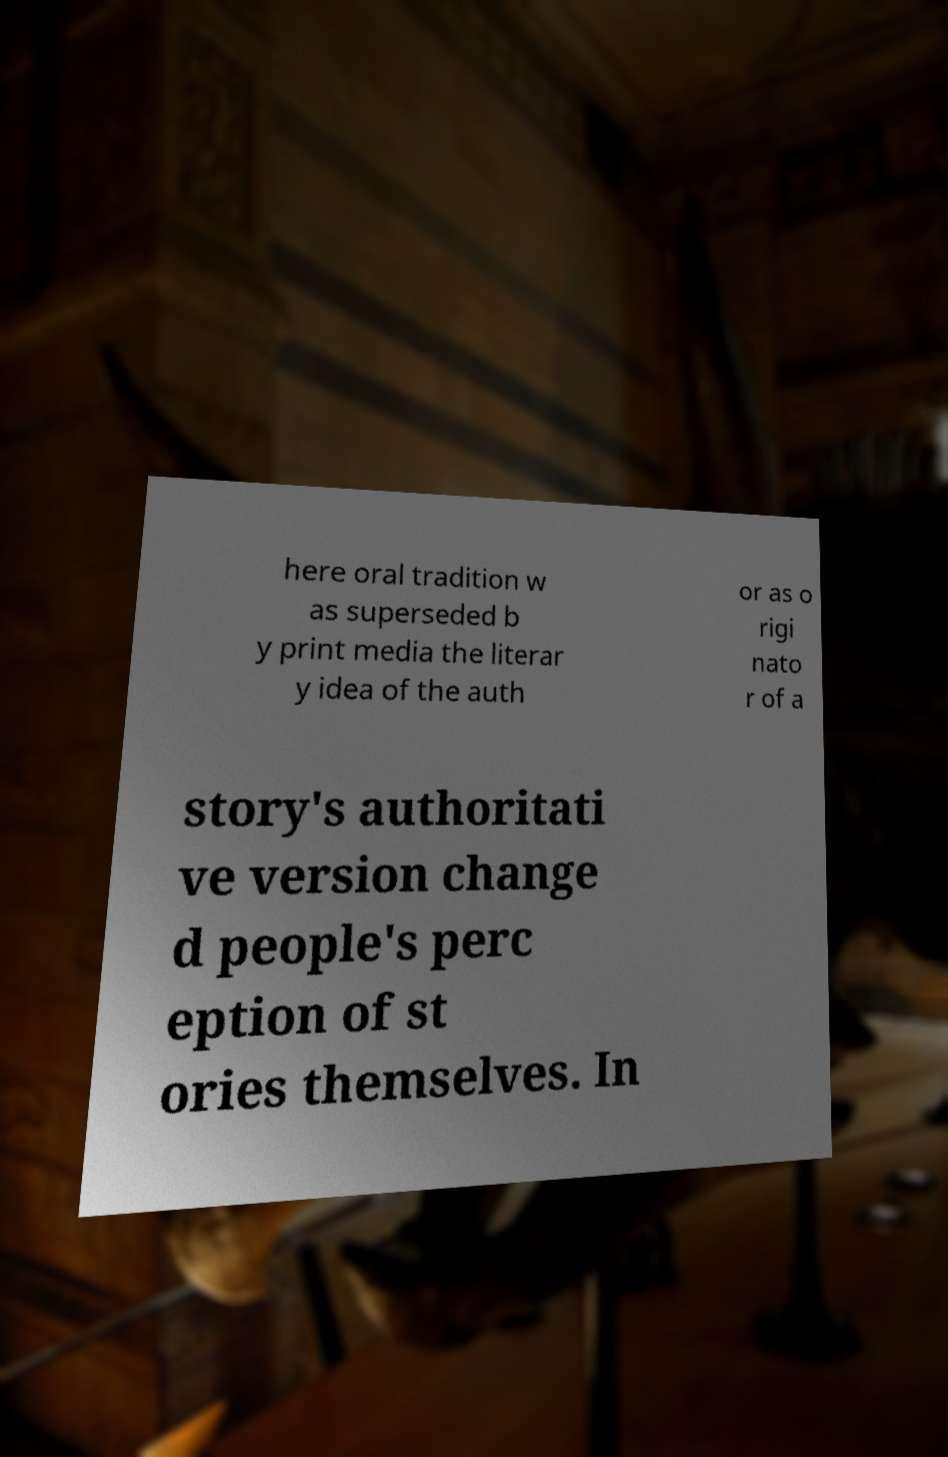There's text embedded in this image that I need extracted. Can you transcribe it verbatim? here oral tradition w as superseded b y print media the literar y idea of the auth or as o rigi nato r of a story's authoritati ve version change d people's perc eption of st ories themselves. In 